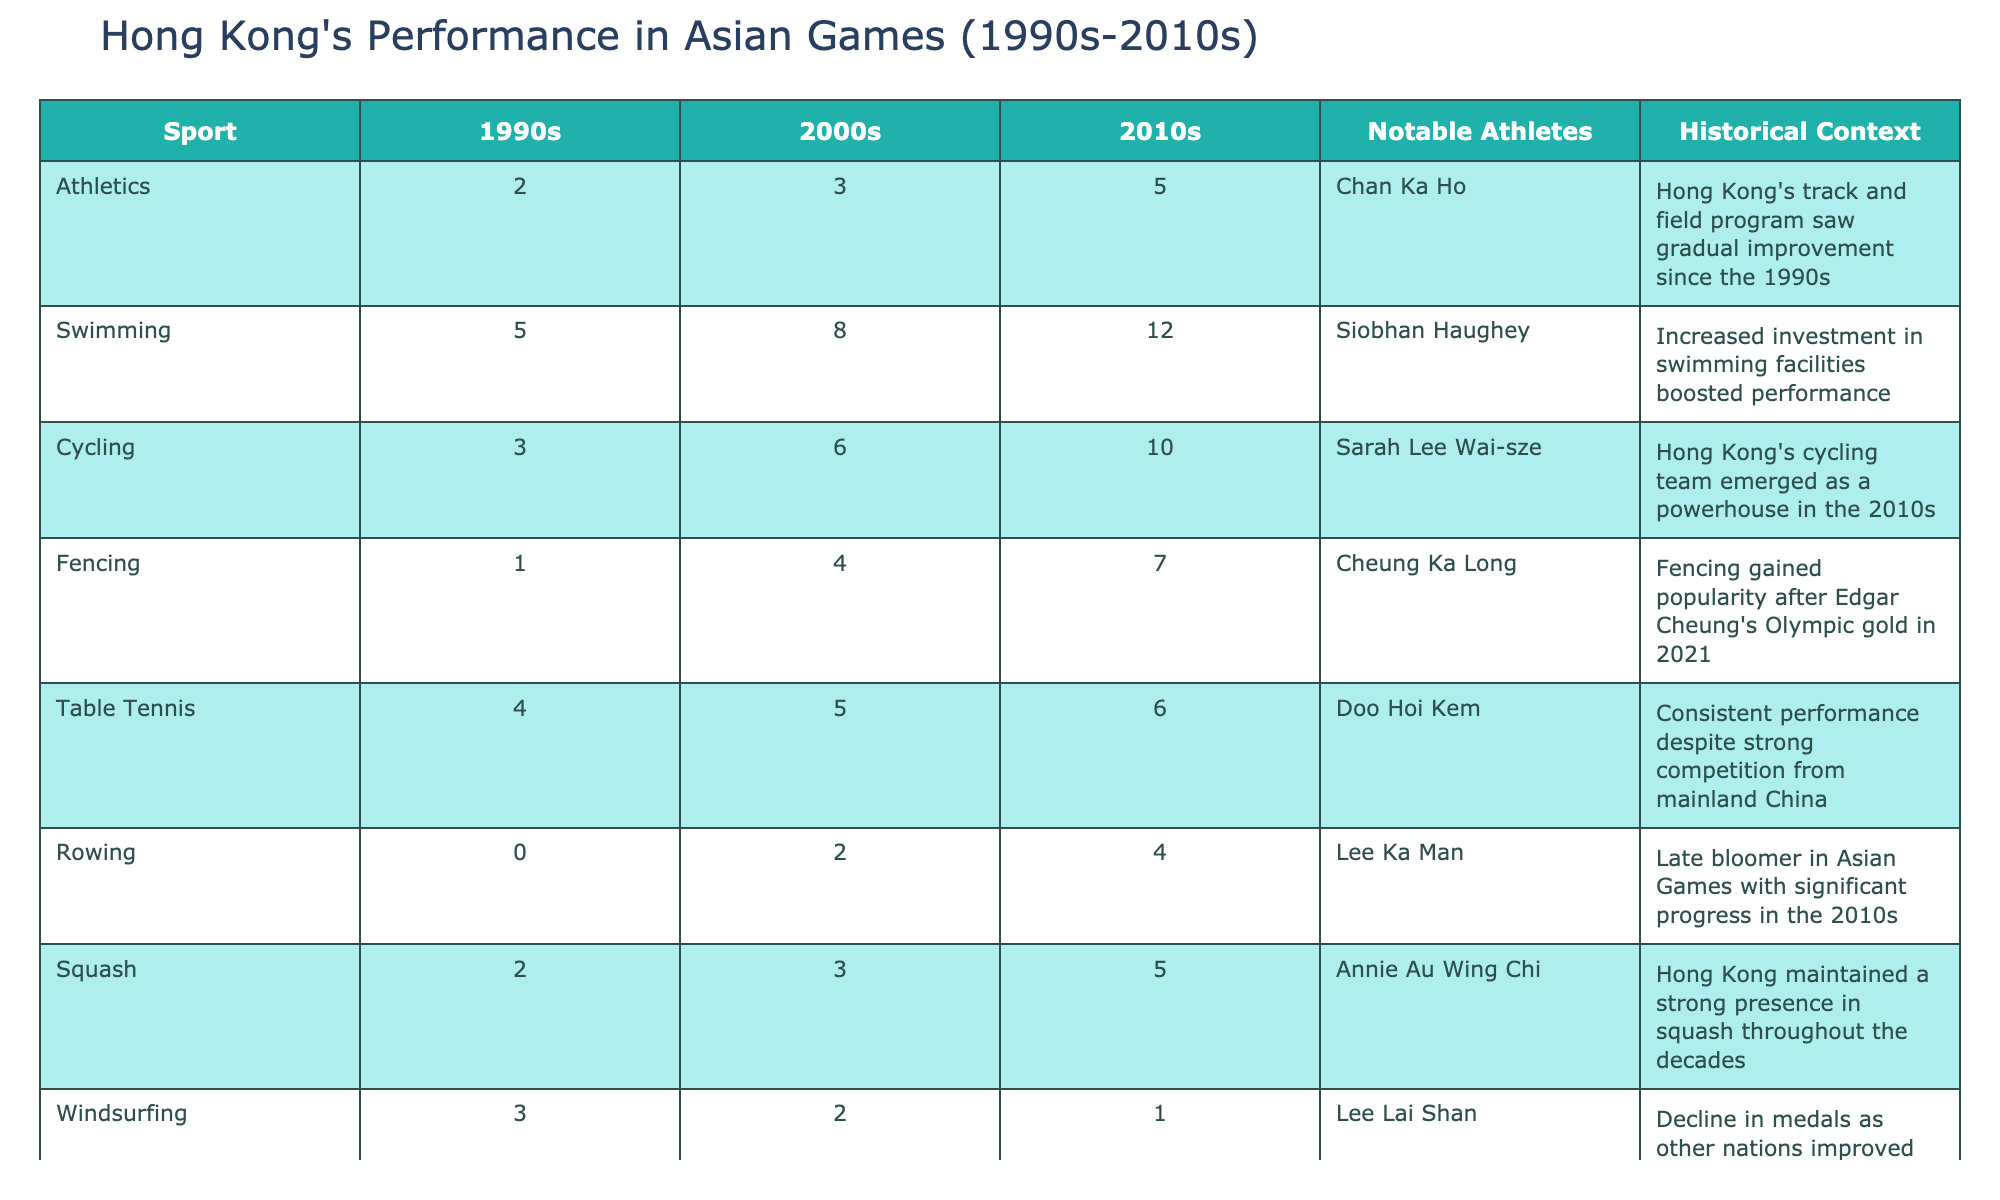What sport had the highest medal count in the 2010s? In the 2010s column, swimming has the highest medal count with 12.
Answer: Swimming How many medals did Hong Kong win in cycling from the 1990s to the 2010s? Summing the medals from the three decades: 3 (1990s) + 6 (2000s) + 10 (2010s) gives a total of 19 medals in cycling.
Answer: 19 Did Hong Kong's performance in windsurfing improve over the decades? In the table, windsurfing had 3 medals in the 1990s, declined to 2 in the 2000s, and then dropped to 1 in the 2010s, indicating a decline in performance.
Answer: No What is the average number of medals Hong Kong won in badminton over the three decades? The total medals in badminton are 1 (1990s) + 2 (2000s) + 3 (2010s) = 6, and then divide by 3 (the number of decades), resulting in an average of 2.
Answer: 2 Which sport saw significant improvement in the number of medals from the 1990s to the 2010s? Comparing the medals: athletics increased from 2 (1990s) to 5 (2010s), cycling from 3 (1990s) to 10 (2010s), and karate from 0 (1990s) to 3 (2010s). All these sports saw improvement, but cycling had the most significant increase of 7 medals.
Answer: Cycling Was Lee Ka Man a notable athlete in rowing? Rowing's notable athlete in the table is Lee Ka Man.
Answer: Yes How did the total medal counts compare between athletics and fencing in the 2000s? Athletics had 3 medals and fencing had 4 medals in the 2000s; this means that fencing outperformed athletics by 1 medal.
Answer: Fencing outperformed athletics Which sport had the same medal count in the 1990s and the 2000s? Table tennis has 4 medals in the 1990s and 5 in the 2000s, indicating it did not have the same count; however, windsurfing had the same count of 3 medals in the 1990s and 2 in the 2000s and thus it was not consistent, but badminton had 1 and 2 in the two decades respectively, so only no sport had the same count. Thus, this question is answered stating that "No sport."
Answer: No sport 